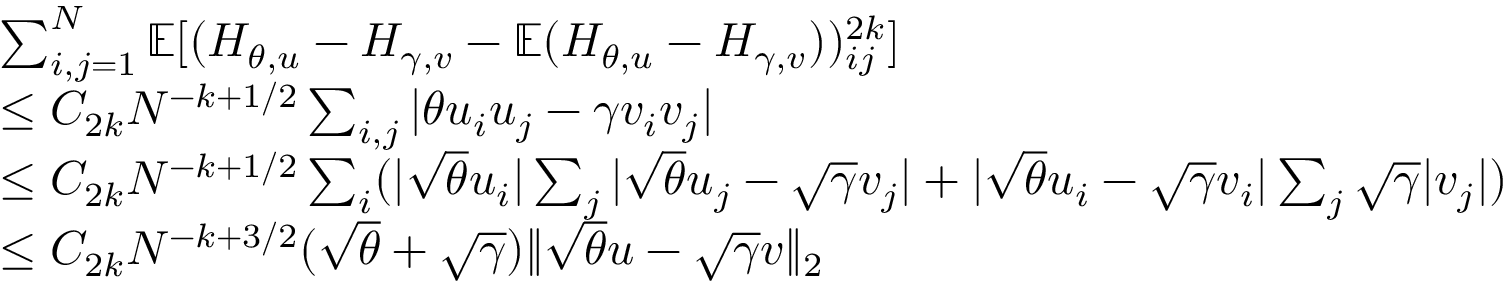Convert formula to latex. <formula><loc_0><loc_0><loc_500><loc_500>\begin{array} { r l } & { \sum _ { i , j = 1 } ^ { N } \mathbb { E } [ ( H _ { \theta , u } - H _ { \gamma , v } - \mathbb { E } ( H _ { \theta , u } - H _ { \gamma , v } ) ) _ { i j } ^ { 2 k } ] } \\ & { \leq C _ { 2 k } N ^ { - k + 1 / 2 } \sum _ { i , j } | \theta u _ { i } u _ { j } - \gamma v _ { i } v _ { j } | } \\ & { \leq C _ { 2 k } N ^ { - k + 1 / 2 } \sum _ { i } ( | \sqrt { \theta } u _ { i } | \sum _ { j } | \sqrt { \theta } u _ { j } - \sqrt { \gamma } v _ { j } | + | \sqrt { \theta } u _ { i } - \sqrt { \gamma } v _ { i } | \sum _ { j } \sqrt { \gamma } | v _ { j } | ) } \\ & { \leq C _ { 2 k } N ^ { - k + 3 / 2 } ( \sqrt { \theta } + \sqrt { \gamma } ) \| \sqrt { \theta } u - \sqrt { \gamma } v \| _ { 2 } } \end{array}</formula> 